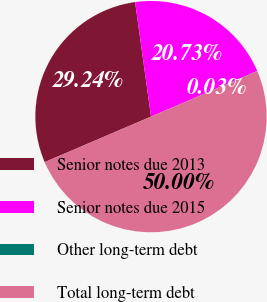<chart> <loc_0><loc_0><loc_500><loc_500><pie_chart><fcel>Senior notes due 2013<fcel>Senior notes due 2015<fcel>Other long-term debt<fcel>Total long-term debt<nl><fcel>29.24%<fcel>20.73%<fcel>0.03%<fcel>50.0%<nl></chart> 